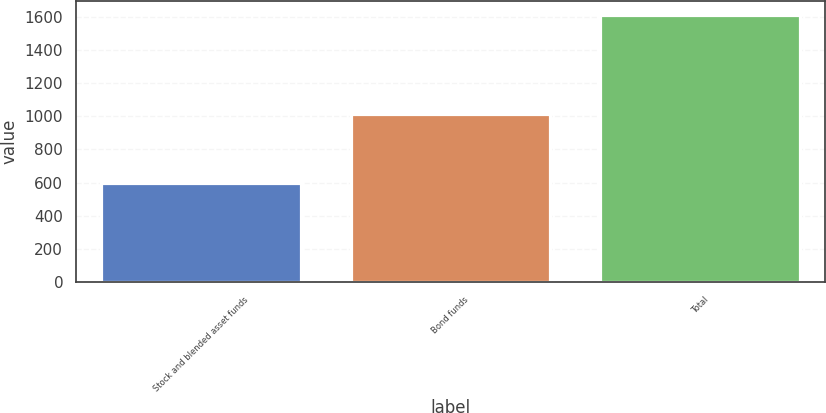Convert chart to OTSL. <chart><loc_0><loc_0><loc_500><loc_500><bar_chart><fcel>Stock and blended asset funds<fcel>Bond funds<fcel>Total<nl><fcel>599.8<fcel>1012.5<fcel>1612.3<nl></chart> 